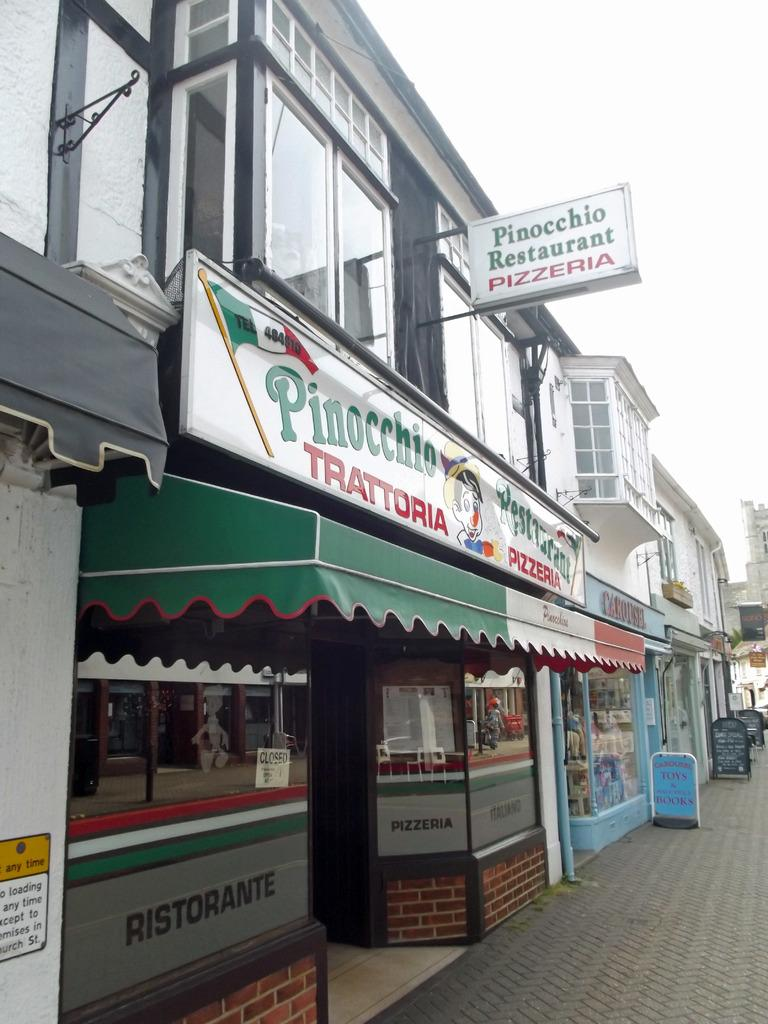<image>
Offer a succinct explanation of the picture presented. Pizza place with a giant sign that says Pinocchio Restaurant Pizzeria. 